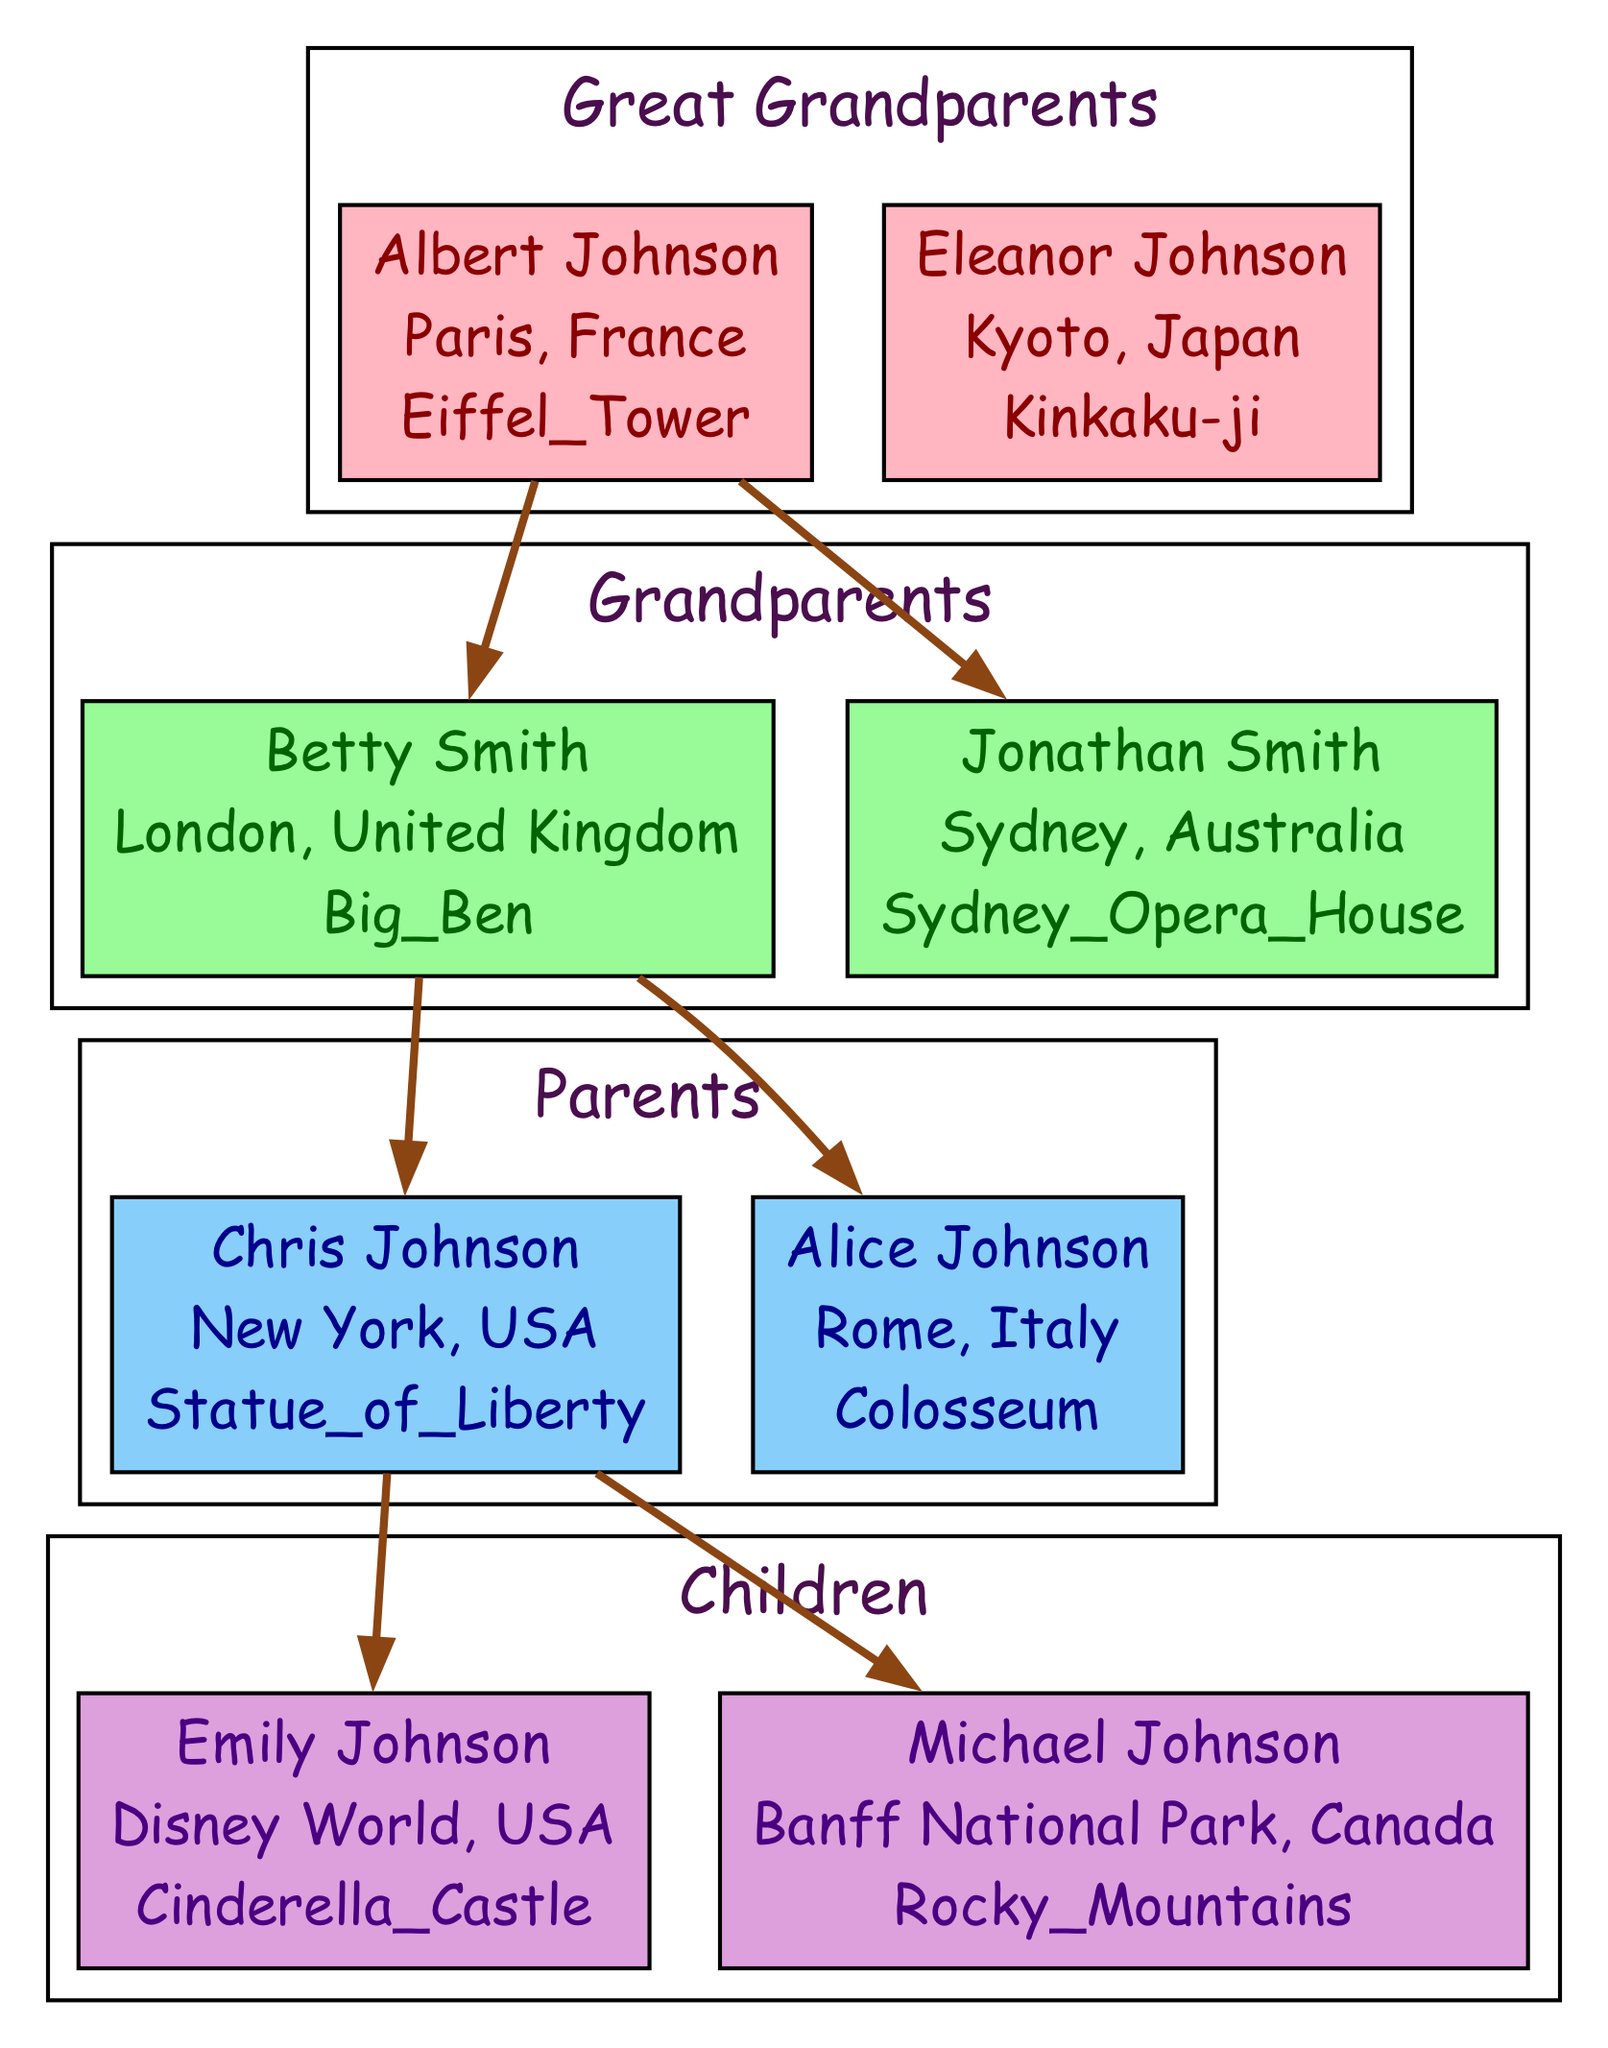What is the favorite destination of Emily Johnson? By examining the member "Emily Johnson" under the "Children" generation, we see that her favorite destination is listed as "Disney World, USA".
Answer: Disney World, USA How many members are in the "Grandparents" generation? The "Grandparents" generation contains two members: "Betty Smith" and "Jonathan Smith". Therefore, the total count is 2.
Answer: 2 Which landmark represents Jonathan Smith's favorite destination? Looking at the data for "Jonathan Smith", we find that his favorite destination is "Sydney, Australia", represented by the "Sydney Opera House" icon.
Answer: Sydney Opera House Who are the parents of Michael Johnson? To find out Michael Johnson's parents, we need to look at the "Parents" generation above him. The members are "Chris Johnson" and "Alice Johnson", who are his parents.
Answer: Chris Johnson and Alice Johnson Which generation does Albert Johnson belong to? Albert Johnson is listed under the "Great Grandparents" generation. This is clearly indicated in the family tree data.
Answer: Great Grandparents What is the favorite destination of Alice Johnson? Looking at the member "Alice Johnson" in the "Parents" generation, her favorite destination is noted as "Rome, Italy".
Answer: Rome, Italy How many total generations are represented in the family tree? The family tree includes four generations: "Great Grandparents", "Grandparents", "Parents", and "Children". That sums up to a total of 4 generations.
Answer: 4 What is the favorite destination for the Great Grandmother? Focusing on Eleanor Johnson, who is listed as a member of the "Great Grandparents" generation, her favorite destination is "Kyoto, Japan".
Answer: Kyoto, Japan Which member's favorite destination has an icon of a castle? Emily Johnson's favorite destination is represented by the "Cinderella Castle" icon, indicating her choice of "Disney World, USA".
Answer: Emily Johnson 